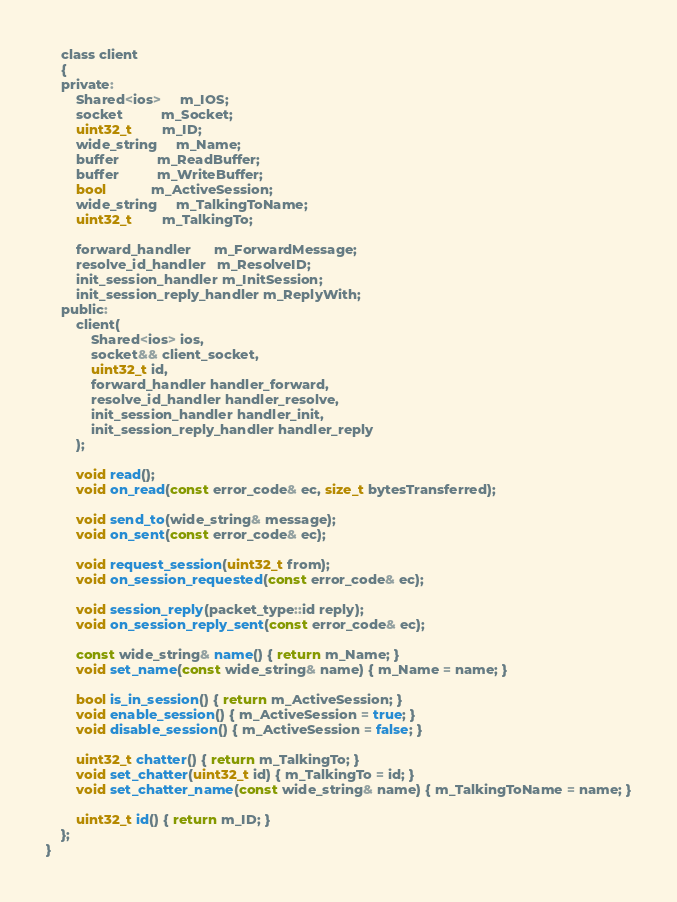<code> <loc_0><loc_0><loc_500><loc_500><_C_>
    class client
    {
    private:
        Shared<ios>     m_IOS;
        socket          m_Socket;
        uint32_t        m_ID;
        wide_string     m_Name;
        buffer          m_ReadBuffer;
        buffer          m_WriteBuffer;
        bool            m_ActiveSession;
        wide_string     m_TalkingToName;
        uint32_t        m_TalkingTo;

        forward_handler      m_ForwardMessage;
        resolve_id_handler   m_ResolveID;
        init_session_handler m_InitSession;
        init_session_reply_handler m_ReplyWith;
    public:
        client(
            Shared<ios> ios, 
            socket&& client_socket, 
            uint32_t id, 
            forward_handler handler_forward,
            resolve_id_handler handler_resolve,
            init_session_handler handler_init,
            init_session_reply_handler handler_reply
        );

        void read();
        void on_read(const error_code& ec, size_t bytesTransferred);

        void send_to(wide_string& message);
        void on_sent(const error_code& ec);

        void request_session(uint32_t from);
        void on_session_requested(const error_code& ec);

        void session_reply(packet_type::id reply);
        void on_session_reply_sent(const error_code& ec);

        const wide_string& name() { return m_Name; }
        void set_name(const wide_string& name) { m_Name = name; }

        bool is_in_session() { return m_ActiveSession; }
        void enable_session() { m_ActiveSession = true; }
        void disable_session() { m_ActiveSession = false; }

        uint32_t chatter() { return m_TalkingTo; }
        void set_chatter(uint32_t id) { m_TalkingTo = id; }
        void set_chatter_name(const wide_string& name) { m_TalkingToName = name; }

        uint32_t id() { return m_ID; }
    };
}
</code> 